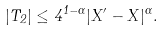Convert formula to latex. <formula><loc_0><loc_0><loc_500><loc_500>| T _ { 2 } | \leq 4 ^ { 1 - \alpha } | X ^ { \prime } - X | ^ { \alpha } .</formula> 